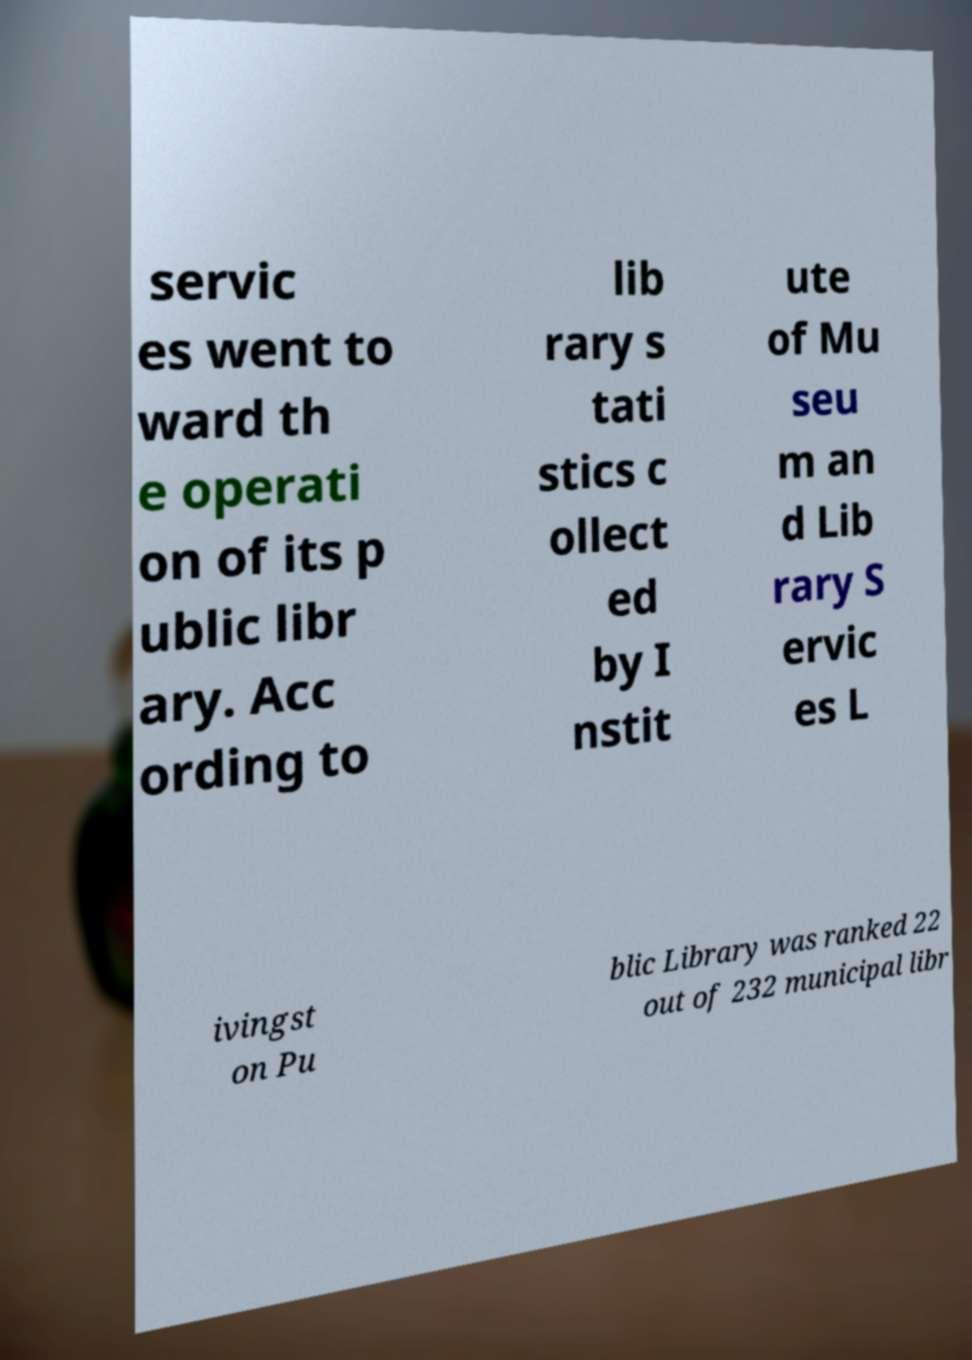Please identify and transcribe the text found in this image. servic es went to ward th e operati on of its p ublic libr ary. Acc ording to lib rary s tati stics c ollect ed by I nstit ute of Mu seu m an d Lib rary S ervic es L ivingst on Pu blic Library was ranked 22 out of 232 municipal libr 